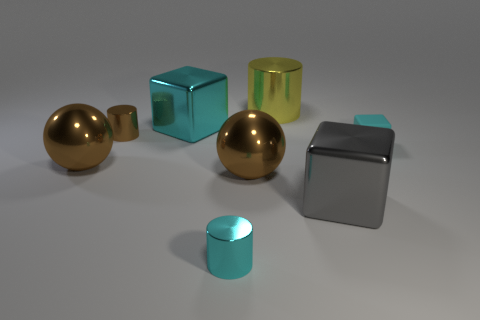What number of big brown metal balls are on the left side of the small shiny cylinder that is on the left side of the large cyan block? 1 